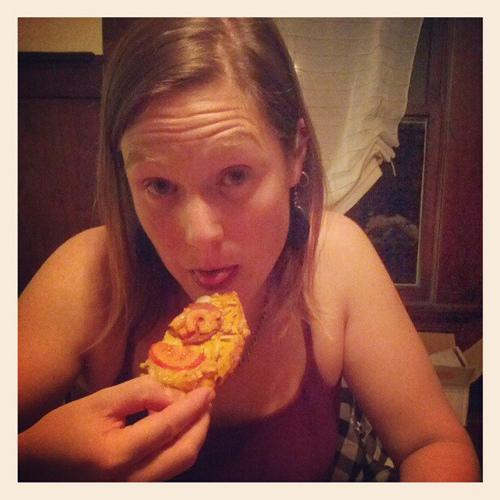What kind of food does the woman hold in her hand? The woman is holding a slice of pizza or an open face sandwich. Count the number of visible toppings on the food the woman is holding. There are three visible toppings: a slice of tomato, sausage, and cheese. Mention an accessory the woman is wearing in her ear. The woman is wearing a long earring in her ear. What is the woman in the image doing? The woman is eating a snack, specifically an open face sandwich or a slice of pizza. What color is the tank top worn by the woman in the image? The tank top worn by the woman is red or purple. Describe the curtain seen in the image. white curtain lifted up Provide a description of the girl's eyes and eyebrows. left eye: open, left eyebrow: blonde, right eye: open, right eyebrow: blonde What is the woman doing with her tongue? sticking it out Identify the physical feature that is focused on the woman's face at X:121 Y:130. blonde eyebrows What color wall is the woman sitting against? brown Which of the following toppings is on the pizza: pepperoni, sausage, olives, or mushrooms? sausage Can you find an open cardboard box in the image? If yes, describe its position. Yes, it is behind the woman. What can you infer about the sandwich based on X:132 Y:288 context? woman holding it in her hand What is the girl wearing in the image? red tank top What color is the woman's tank top? red What is the pattern found on the object located at X:334 Y:408? black and white checkered pattern What is the woman doing at X:72 Y:20 in the image? eating a snack What is on top of the sandwich? tomato slice Create a sentence describing the woman's overall appearance and what she is doing. A woman with brown hair, a red tank top, and earrings is eating a slice of pizza. What type of food item does the woman seem to be indulging in at X:24 Y:17? slice of pizza Express the presence and appearance of a necklace around the woman's neck. partial view of gold necklace around womans neck Describe the hair and clothing style of the woman centered around X:94 Y:27. Long hair, red tank top 